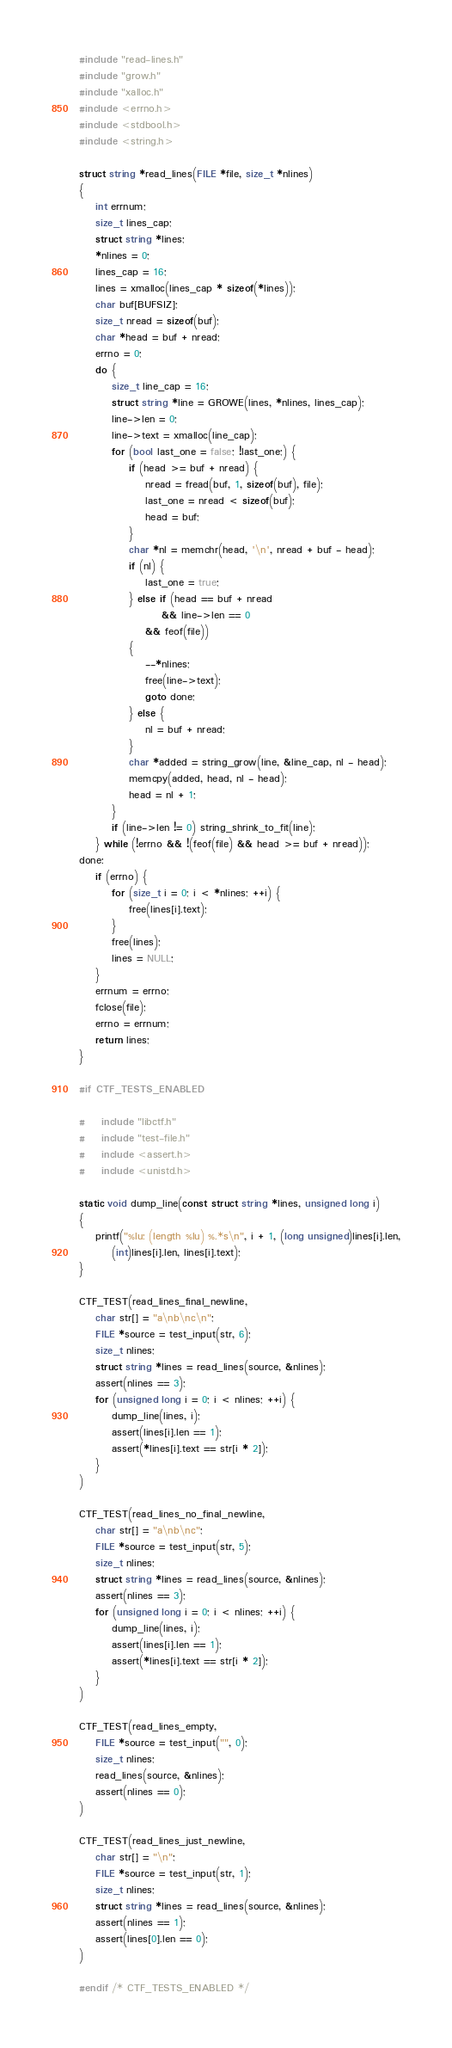Convert code to text. <code><loc_0><loc_0><loc_500><loc_500><_C_>#include "read-lines.h"
#include "grow.h"
#include "xalloc.h"
#include <errno.h>
#include <stdbool.h>
#include <string.h>

struct string *read_lines(FILE *file, size_t *nlines)
{
	int errnum;
	size_t lines_cap;
	struct string *lines;
	*nlines = 0;
	lines_cap = 16;
	lines = xmalloc(lines_cap * sizeof(*lines));
	char buf[BUFSIZ];
	size_t nread = sizeof(buf);
	char *head = buf + nread;
	errno = 0;
	do {
		size_t line_cap = 16;
		struct string *line = GROWE(lines, *nlines, lines_cap);
		line->len = 0;
		line->text = xmalloc(line_cap);
		for (bool last_one = false; !last_one;) {
			if (head >= buf + nread) {
				nread = fread(buf, 1, sizeof(buf), file);
				last_one = nread < sizeof(buf);
				head = buf;
			}
			char *nl = memchr(head, '\n', nread + buf - head);
			if (nl) {
				last_one = true;
			} else if (head == buf + nread
			        && line->len == 0
				&& feof(file))
			{
				--*nlines;
				free(line->text);
				goto done;
			} else {
				nl = buf + nread;
			}
			char *added = string_grow(line, &line_cap, nl - head);
			memcpy(added, head, nl - head);
			head = nl + 1;
		}
		if (line->len != 0) string_shrink_to_fit(line);
	} while (!errno && !(feof(file) && head >= buf + nread));
done:
	if (errno) {
		for (size_t i = 0; i < *nlines; ++i) {
			free(lines[i].text);
		}
		free(lines);
		lines = NULL;
	}
	errnum = errno;
	fclose(file);
	errno = errnum;
	return lines;
}

#if CTF_TESTS_ENABLED

#	include "libctf.h"
#	include "test-file.h"
#	include <assert.h>
#	include <unistd.h>

static void dump_line(const struct string *lines, unsigned long i)
{
	printf("%lu: (length %lu) %.*s\n", i + 1, (long unsigned)lines[i].len,
		(int)lines[i].len, lines[i].text);
}

CTF_TEST(read_lines_final_newline,
	char str[] = "a\nb\nc\n";
	FILE *source = test_input(str, 6);
	size_t nlines;
	struct string *lines = read_lines(source, &nlines);
	assert(nlines == 3);
	for (unsigned long i = 0; i < nlines; ++i) {
		dump_line(lines, i);
		assert(lines[i].len == 1);
		assert(*lines[i].text == str[i * 2]);
	}
)

CTF_TEST(read_lines_no_final_newline,
	char str[] = "a\nb\nc";
	FILE *source = test_input(str, 5);
	size_t nlines;
	struct string *lines = read_lines(source, &nlines);
	assert(nlines == 3);
	for (unsigned long i = 0; i < nlines; ++i) {
		dump_line(lines, i);
		assert(lines[i].len == 1);
		assert(*lines[i].text == str[i * 2]);
	}
)

CTF_TEST(read_lines_empty,
	FILE *source = test_input("", 0);
	size_t nlines;
	read_lines(source, &nlines);
	assert(nlines == 0);
)

CTF_TEST(read_lines_just_newline,
	char str[] = "\n";
	FILE *source = test_input(str, 1);
	size_t nlines;
	struct string *lines = read_lines(source, &nlines);
	assert(nlines == 1);
	assert(lines[0].len == 0);
)

#endif /* CTF_TESTS_ENABLED */
</code> 